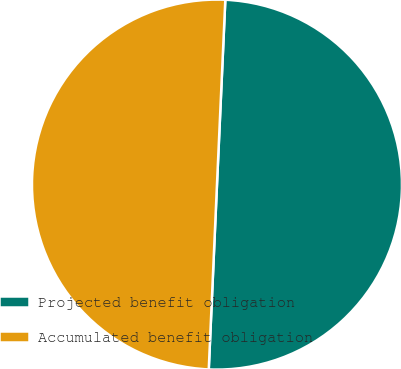Convert chart to OTSL. <chart><loc_0><loc_0><loc_500><loc_500><pie_chart><fcel>Projected benefit obligation<fcel>Accumulated benefit obligation<nl><fcel>49.99%<fcel>50.01%<nl></chart> 